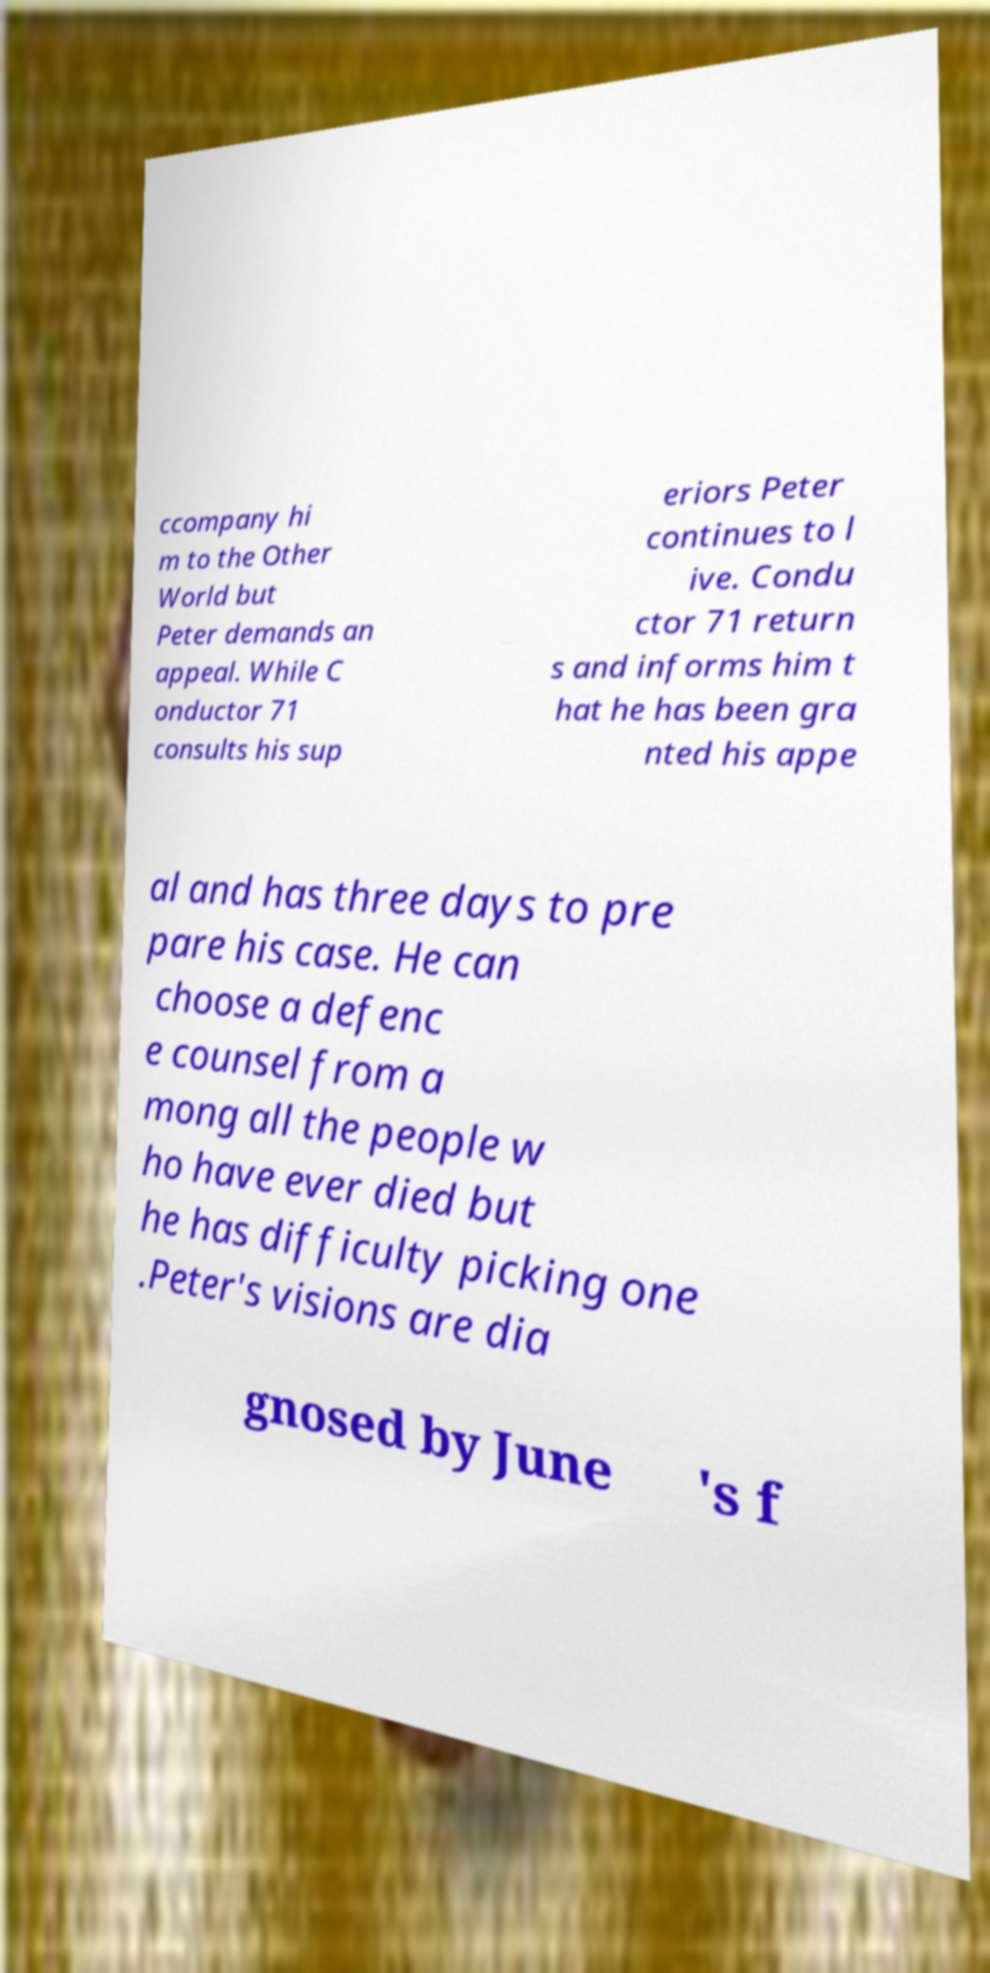There's text embedded in this image that I need extracted. Can you transcribe it verbatim? ccompany hi m to the Other World but Peter demands an appeal. While C onductor 71 consults his sup eriors Peter continues to l ive. Condu ctor 71 return s and informs him t hat he has been gra nted his appe al and has three days to pre pare his case. He can choose a defenc e counsel from a mong all the people w ho have ever died but he has difficulty picking one .Peter's visions are dia gnosed by June 's f 